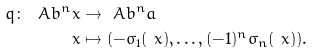Convert formula to latex. <formula><loc_0><loc_0><loc_500><loc_500>q \colon \ A b ^ { n } _ { \ } x & \to \ A b ^ { n } _ { \ } a \\ \ x & \mapsto ( - \sigma _ { 1 } ( \ x ) , \dots , ( - 1 ) ^ { n } \sigma _ { n } ( \ x ) ) .</formula> 